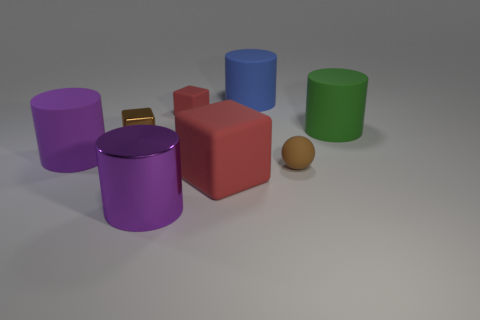What number of rubber cylinders have the same size as the purple rubber thing?
Your answer should be very brief. 2. Are there fewer tiny things that are left of the small matte cube than yellow shiny cubes?
Your response must be concise. No. There is a cylinder that is on the left side of the big purple cylinder that is in front of the big red rubber thing; what is its size?
Keep it short and to the point. Large. What number of objects are either tiny rubber spheres or tiny blue objects?
Make the answer very short. 1. Is there a large object that has the same color as the metallic cylinder?
Your answer should be compact. Yes. Are there fewer small purple matte cylinders than big green rubber things?
Give a very brief answer. Yes. What number of objects are small brown matte balls or red matte cubes behind the small ball?
Give a very brief answer. 2. Are there any brown cylinders that have the same material as the brown sphere?
Provide a succinct answer. No. There is a brown sphere that is the same size as the brown shiny object; what material is it?
Provide a succinct answer. Rubber. What material is the red block in front of the tiny cube that is behind the green rubber cylinder?
Offer a very short reply. Rubber. 